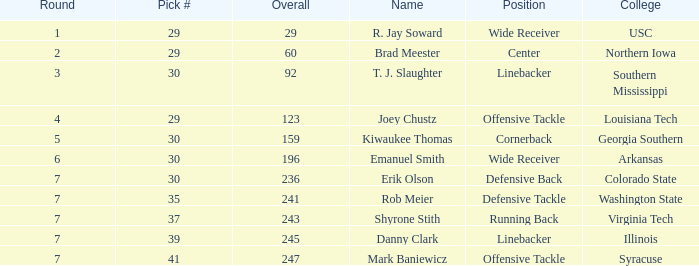Can you give me this table as a dict? {'header': ['Round', 'Pick #', 'Overall', 'Name', 'Position', 'College'], 'rows': [['1', '29', '29', 'R. Jay Soward', 'Wide Receiver', 'USC'], ['2', '29', '60', 'Brad Meester', 'Center', 'Northern Iowa'], ['3', '30', '92', 'T. J. Slaughter', 'Linebacker', 'Southern Mississippi'], ['4', '29', '123', 'Joey Chustz', 'Offensive Tackle', 'Louisiana Tech'], ['5', '30', '159', 'Kiwaukee Thomas', 'Cornerback', 'Georgia Southern'], ['6', '30', '196', 'Emanuel Smith', 'Wide Receiver', 'Arkansas'], ['7', '30', '236', 'Erik Olson', 'Defensive Back', 'Colorado State'], ['7', '35', '241', 'Rob Meier', 'Defensive Tackle', 'Washington State'], ['7', '37', '243', 'Shyrone Stith', 'Running Back', 'Virginia Tech'], ['7', '39', '245', 'Danny Clark', 'Linebacker', 'Illinois'], ['7', '41', '247', 'Mark Baniewicz', 'Offensive Tackle', 'Syracuse']]} What is the lowest Round with Overall of 247 and pick less than 41? None. 